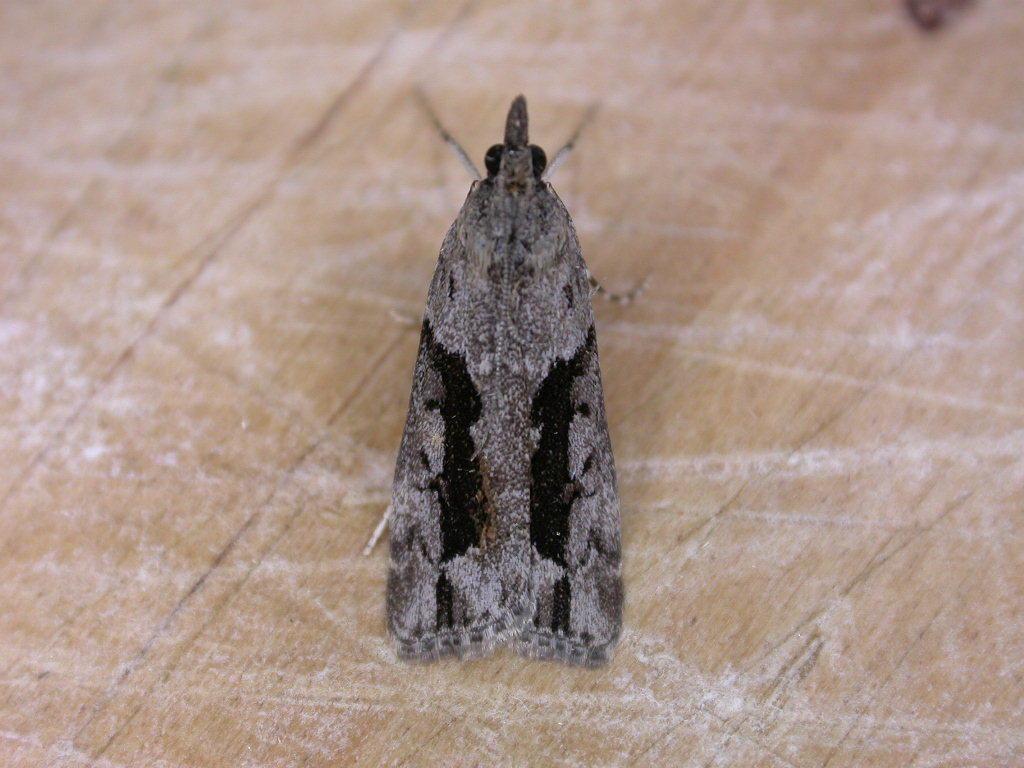Describe this image in one or two sentences. In the picture we can see an insect on the wooden surface. 